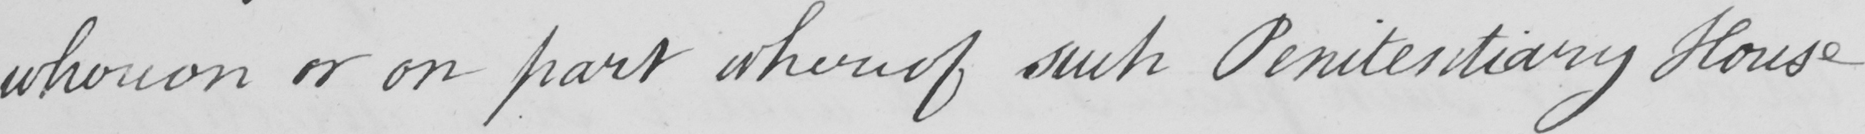Please transcribe the handwritten text in this image. whereon or on part whereof such Penitentiary House 